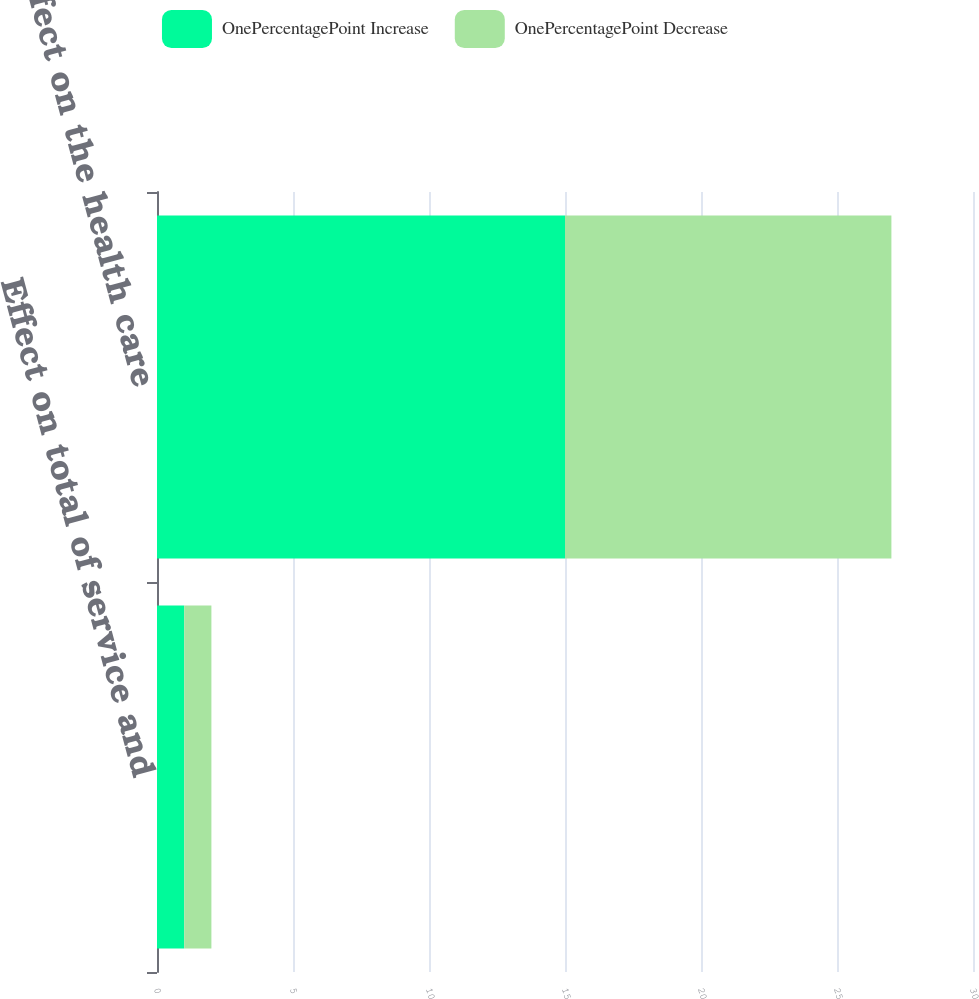<chart> <loc_0><loc_0><loc_500><loc_500><stacked_bar_chart><ecel><fcel>Effect on total of service and<fcel>Effect on the health care<nl><fcel>OnePercentagePoint Increase<fcel>1<fcel>15<nl><fcel>OnePercentagePoint Decrease<fcel>1<fcel>12<nl></chart> 